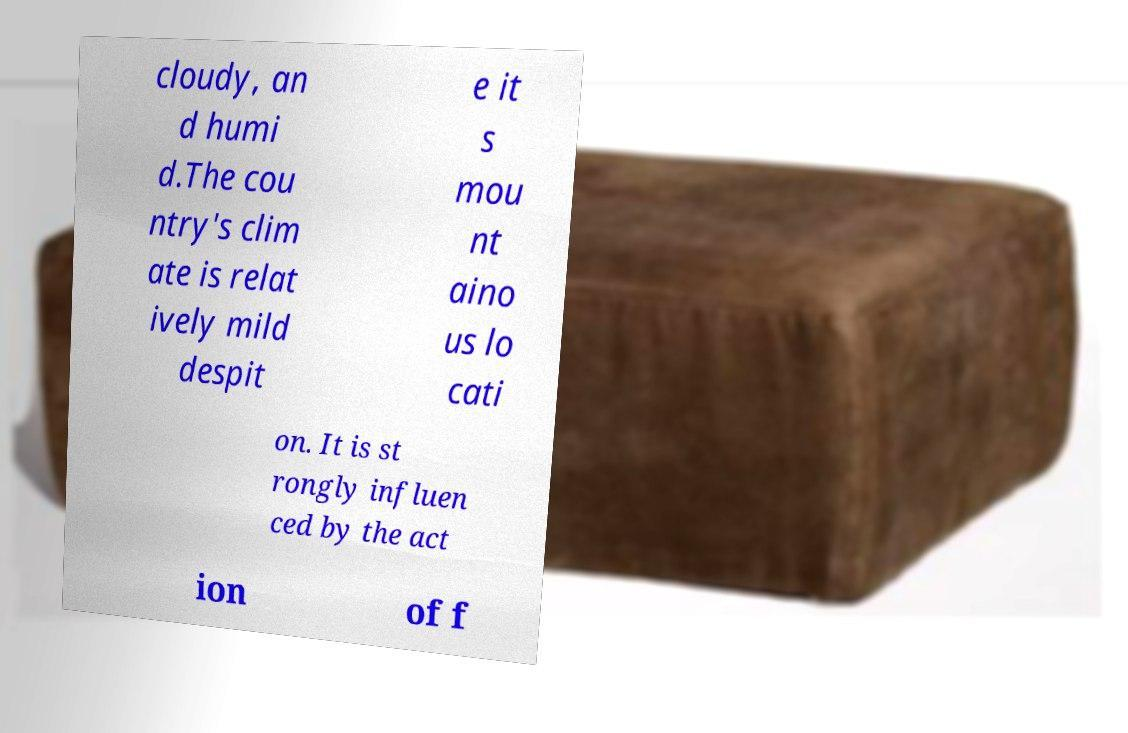There's text embedded in this image that I need extracted. Can you transcribe it verbatim? cloudy, an d humi d.The cou ntry's clim ate is relat ively mild despit e it s mou nt aino us lo cati on. It is st rongly influen ced by the act ion of f 